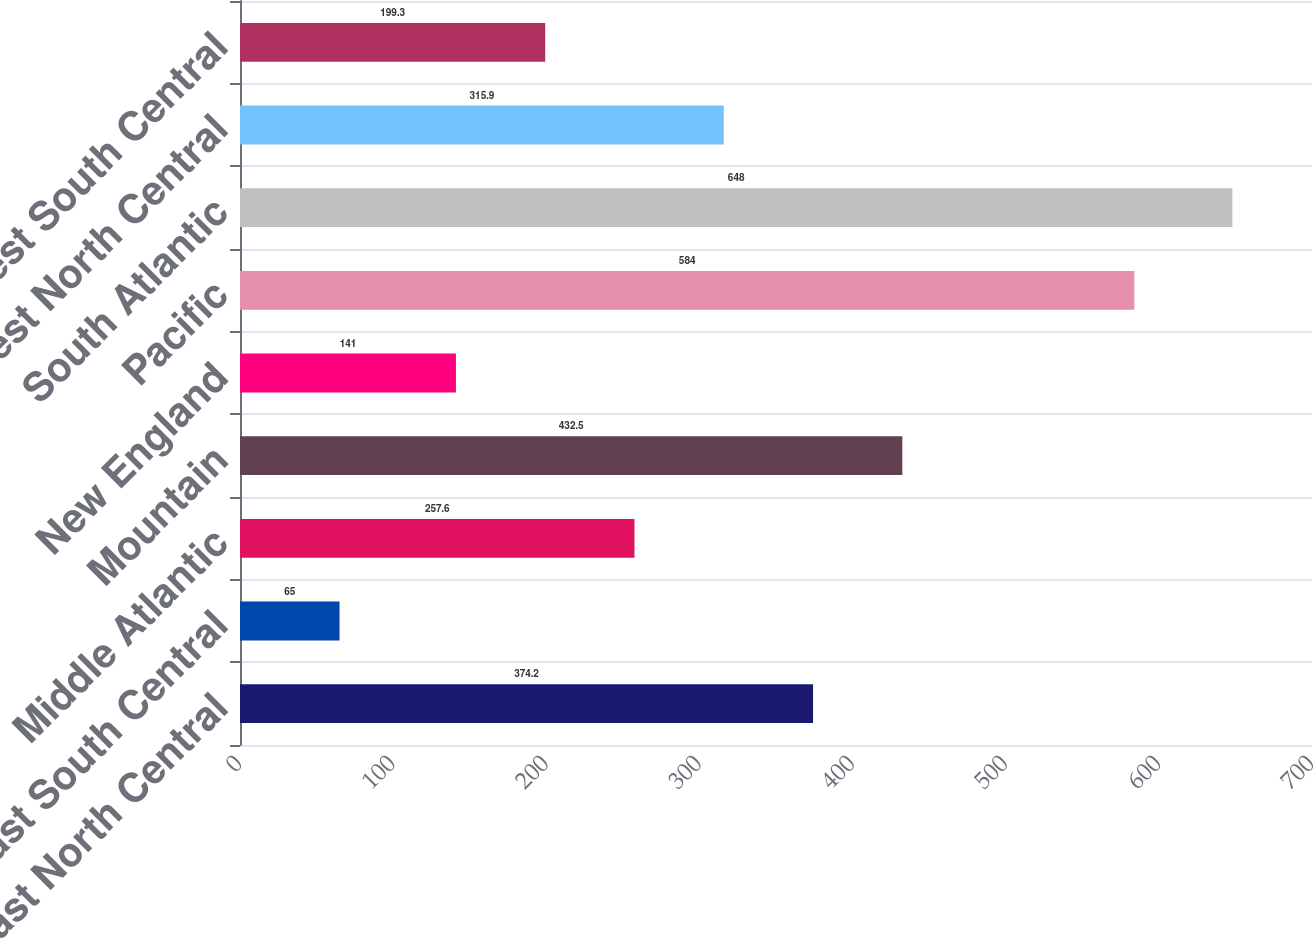<chart> <loc_0><loc_0><loc_500><loc_500><bar_chart><fcel>East North Central<fcel>East South Central<fcel>Middle Atlantic<fcel>Mountain<fcel>New England<fcel>Pacific<fcel>South Atlantic<fcel>West North Central<fcel>West South Central<nl><fcel>374.2<fcel>65<fcel>257.6<fcel>432.5<fcel>141<fcel>584<fcel>648<fcel>315.9<fcel>199.3<nl></chart> 